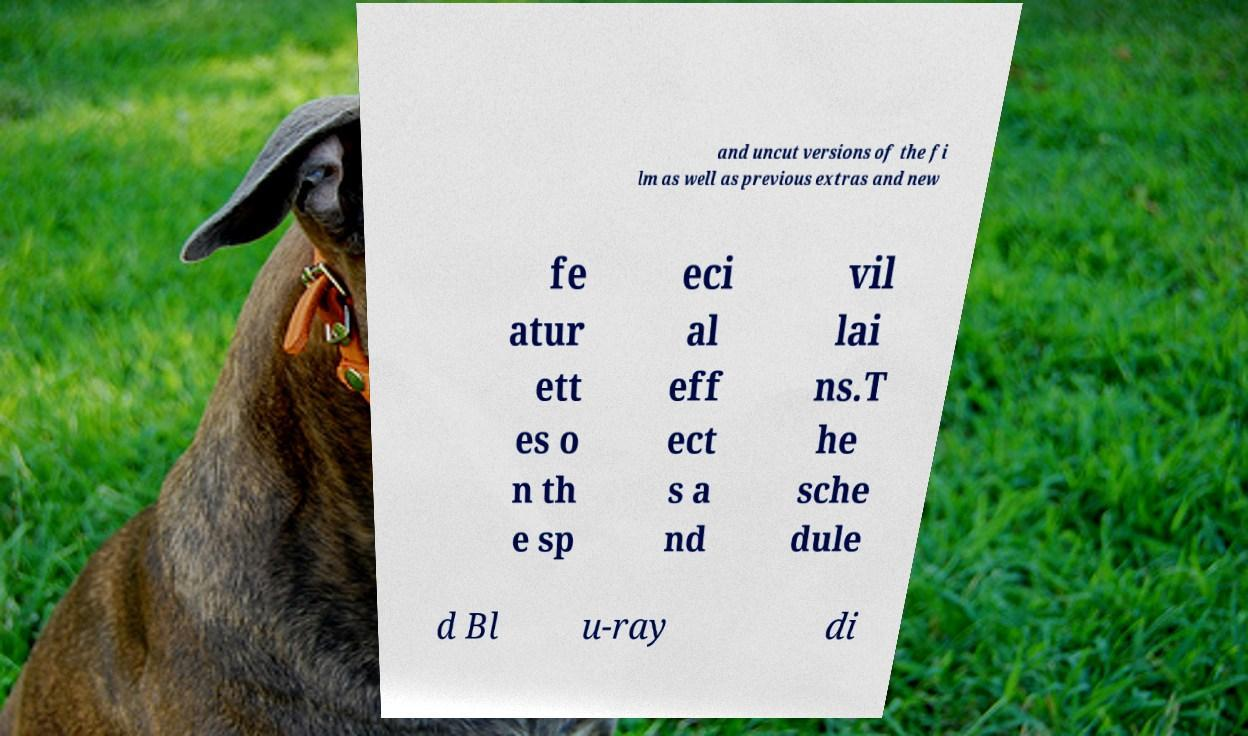For documentation purposes, I need the text within this image transcribed. Could you provide that? and uncut versions of the fi lm as well as previous extras and new fe atur ett es o n th e sp eci al eff ect s a nd vil lai ns.T he sche dule d Bl u-ray di 